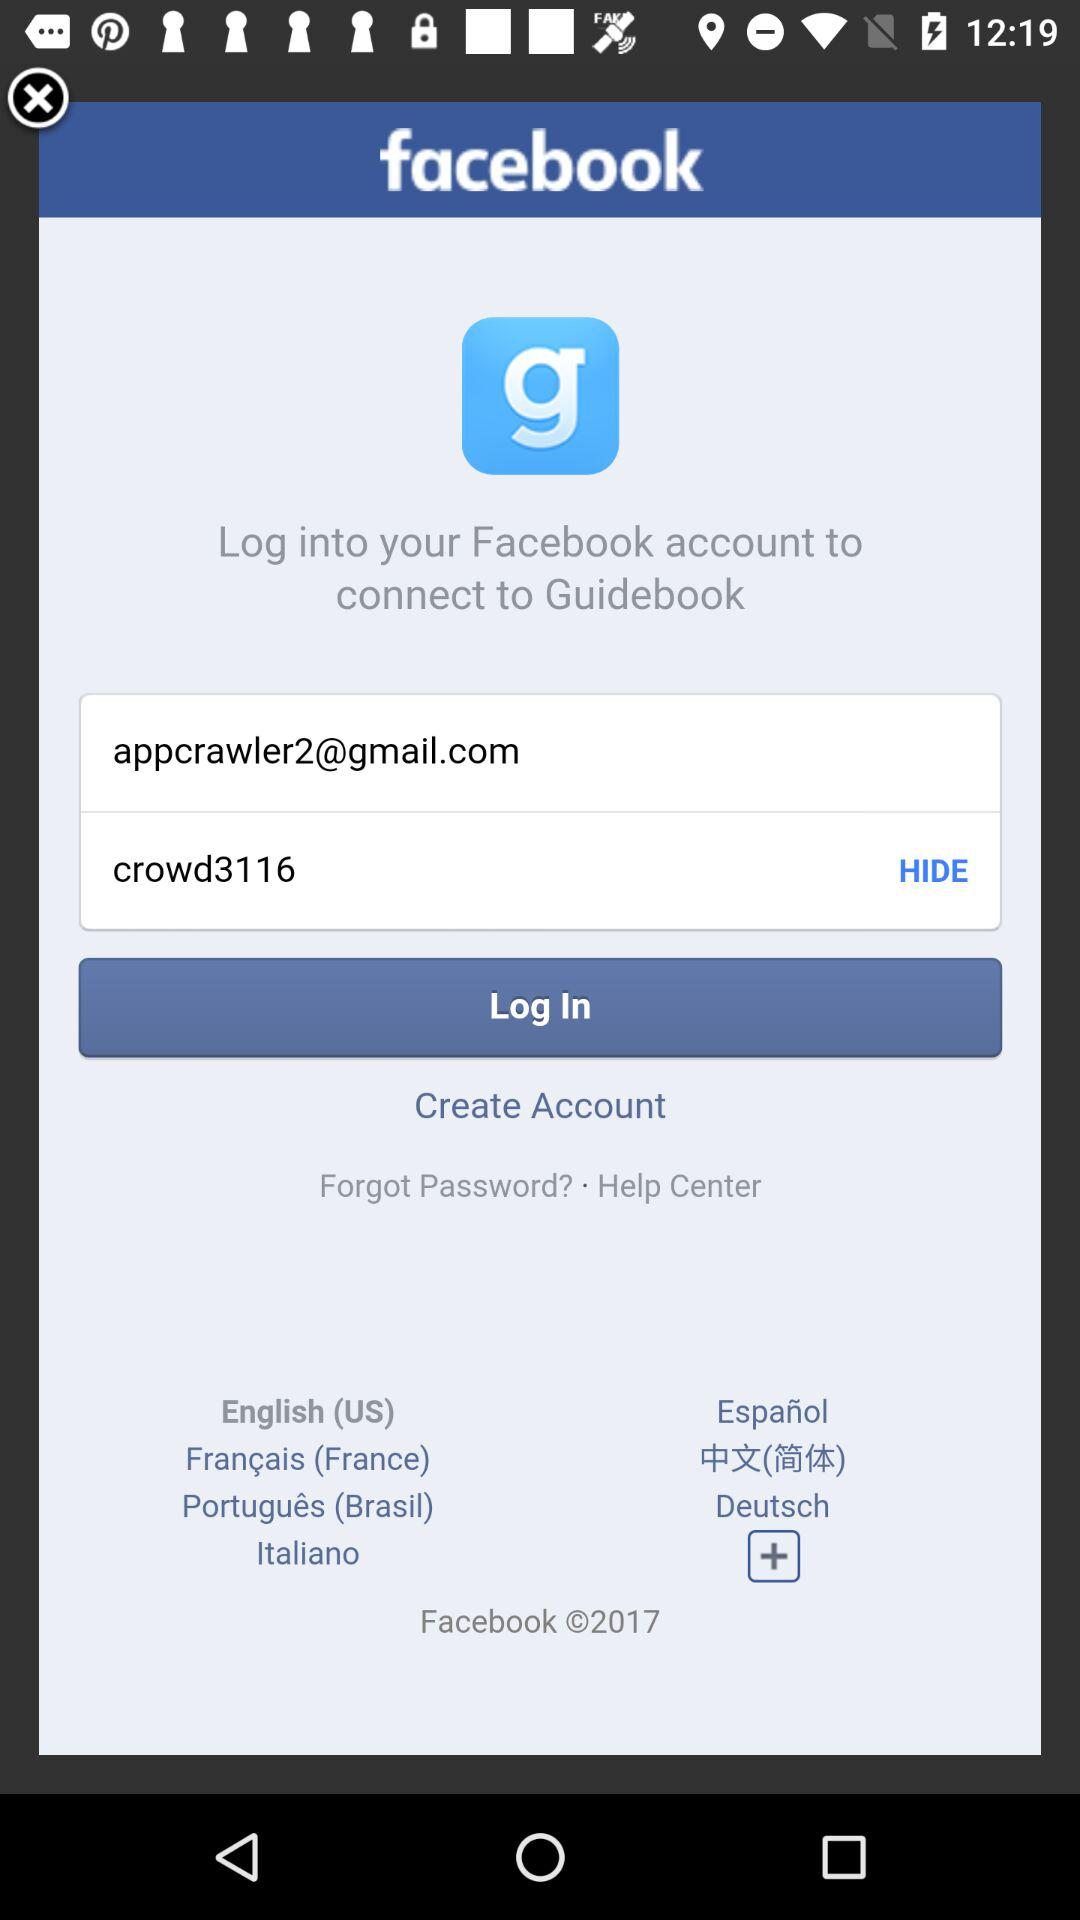What is the email address? The email address is appcrawler2@gmail.com. 